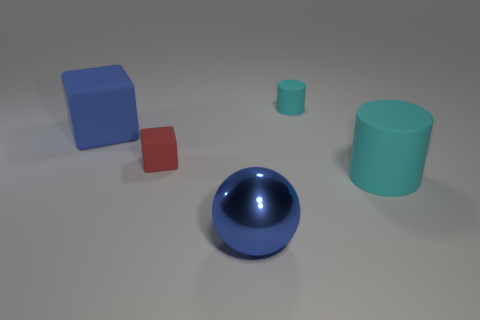Are there any other things that are the same material as the blue ball?
Provide a succinct answer. No. How many other objects are there of the same color as the tiny rubber cylinder?
Provide a short and direct response. 1. What shape is the cyan object that is the same size as the red matte thing?
Your answer should be compact. Cylinder. What is the size of the cyan matte cylinder that is in front of the red rubber block?
Your answer should be compact. Large. Is the color of the thing that is in front of the large cyan cylinder the same as the big matte thing that is on the right side of the red rubber block?
Provide a succinct answer. No. What material is the ball on the right side of the big blue object that is behind the metallic thing in front of the tiny cyan matte object made of?
Your answer should be compact. Metal. Is there another red block of the same size as the red cube?
Offer a very short reply. No. There is a cyan thing that is the same size as the blue cube; what material is it?
Offer a very short reply. Rubber. There is a large rubber thing that is to the right of the red matte cube; what shape is it?
Your answer should be compact. Cylinder. Is the large object that is right of the big metallic ball made of the same material as the tiny thing to the left of the large blue sphere?
Provide a succinct answer. Yes. 